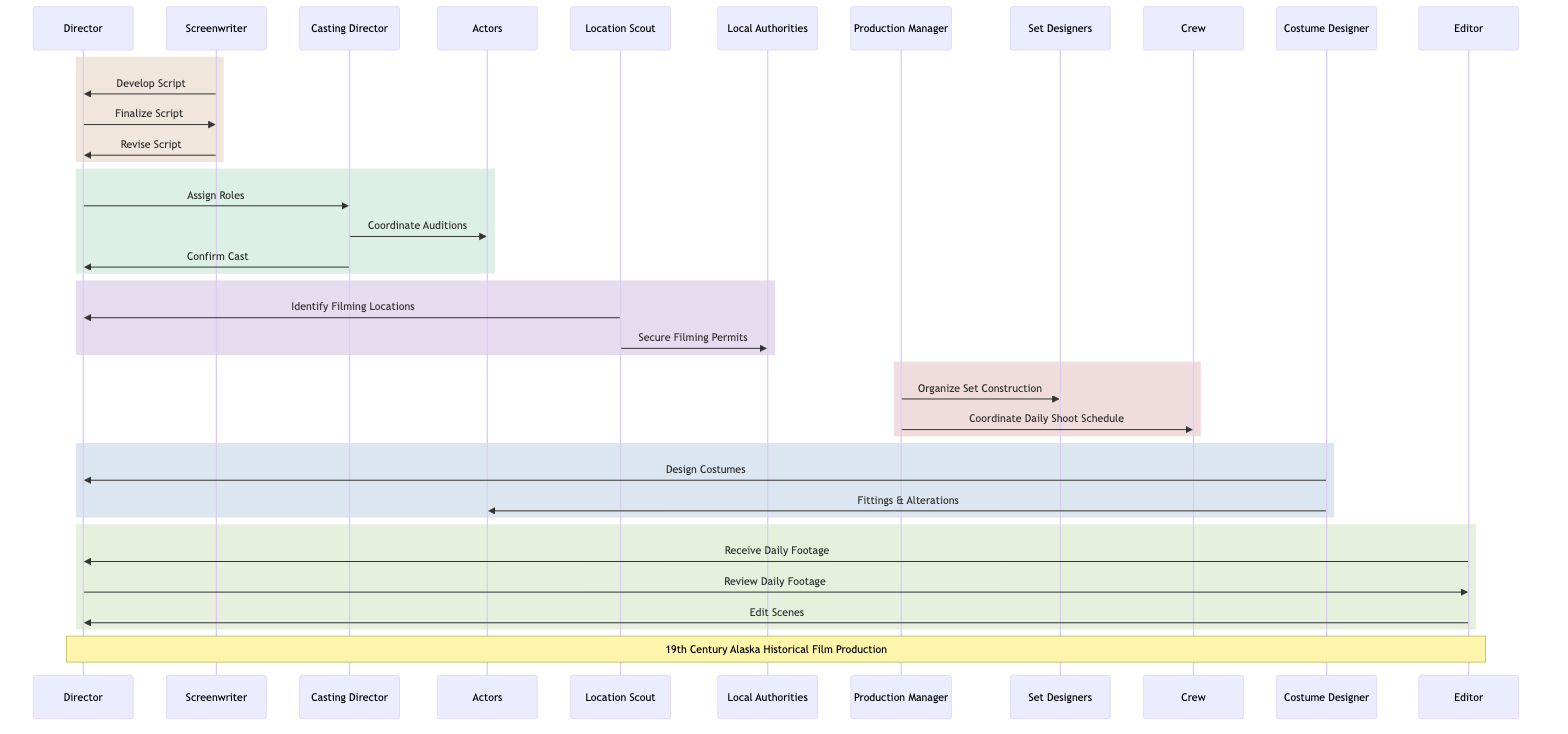What's the first action taken by the Screenwriter? The first action taken by the Screenwriter is "Develop Script," as indicated by the direct arrow from the Screenwriter to the Director in the diagram.
Answer: Develop Script How many main participants are involved in this sequence diagram? There are ten main participants in the diagram, as listed in the sequence diagram: Director, Screenwriter, Casting Director, Actors, Location Scout, Local Authorities, Production Manager, Set Designers, Crew, Costume Designer, and Editor.
Answer: Ten What does the Casting Director do after receiving the role assignment from the Director? After receiving the role assignment, the Casting Director "Coordinate Auditions," as shown by the flow in the diagram, where the Casting Director acts after the Director's action of assigning roles.
Answer: Coordinate Auditions Which participant is responsible for securing filming permits? The participant responsible for securing filming permits is the Location Scout, as indicated by the action "Secure Filming Permits" directed towards the Local Authorities in the diagram.
Answer: Location Scout What does the Editor do after receiving daily footage from the Director? After receiving the daily footage from the Director, the Editor "Edit Scenes," as noted in the sequential actions following the Director's receipt of daily footage.
Answer: Edit Scenes What are the two actions taken by the Costume Designer? The two actions taken by the Costume Designer are "Design Costumes" and "Fittings & Alterations," both of which are directed toward the Director and the Actors, respectively.
Answer: Design Costumes, Fittings & Alterations Which role is directly responsible for scheduling and coordinating the shooting activities? The role responsible for scheduling and coordinating the shooting activities is the Production Manager, indicated by the action "Coordinate Daily Shoot Schedule" directed to the Crew.
Answer: Production Manager How does the Screenwriter ensure historical accuracy in the script development? The Screenwriter ensures historical accuracy in the script development by incorporating feedback and notes, as reflected in the action "Revise Script" directed to the Director in the diagram.
Answer: Revise Script What is the final output of actions concerning the editing process? The final output of actions concerning the editing process includes the steps where the Editor receives daily footage, which is followed by reviewing and editing scenes, culminating in completed edits submitted back to the Director.
Answer: Edit Scenes 